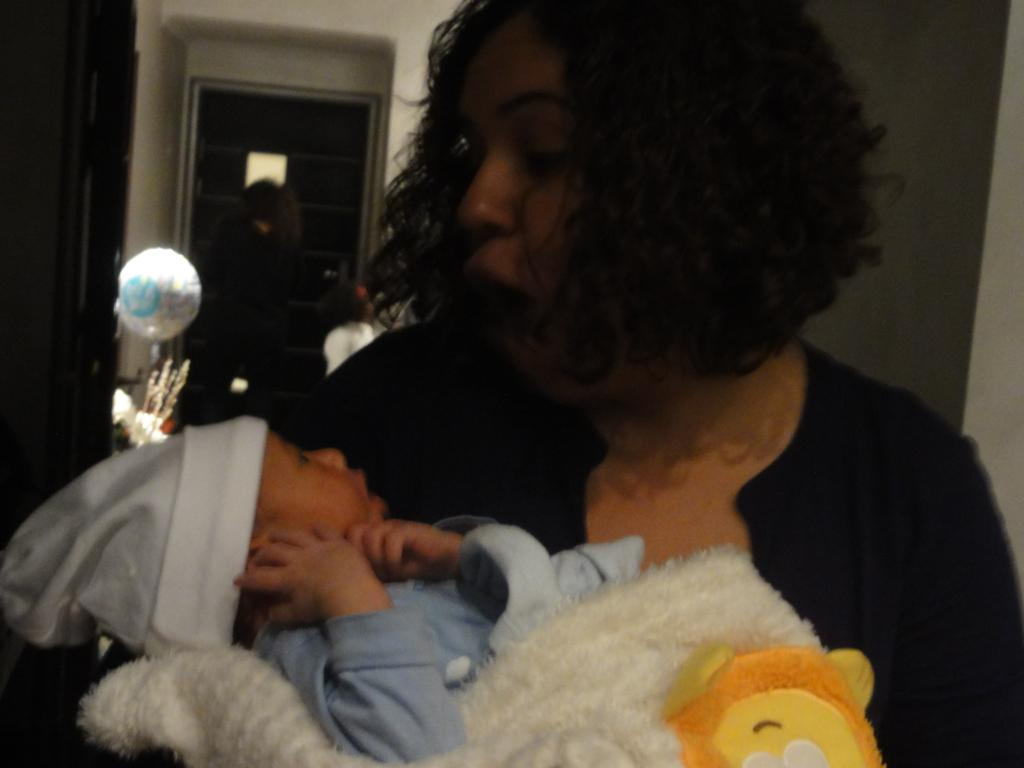What is the person in the image doing? The person is carrying a baby in the image. What can be seen in the background of the image? There is a balloon and two persons standing near a door in the background of the image. What type of straw is the hydrant using in the image? There is no hydrant or straw present in the image. What is the porter's role in the image? There is no porter mentioned or depicted in the image. 